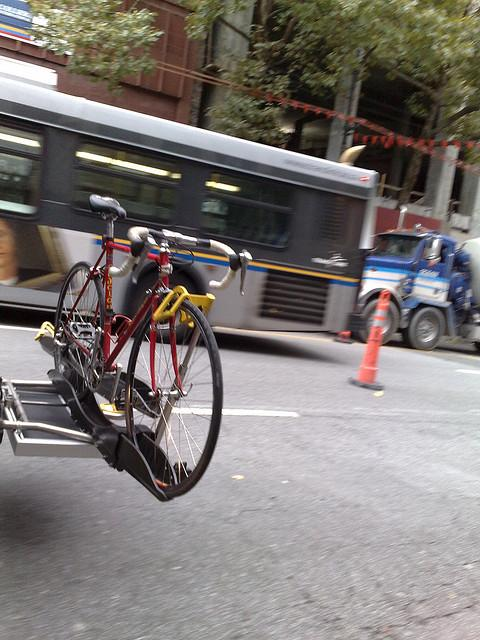What is to the left of the cone?

Choices:
A) helicopter
B) bicycle
C) television
D) bear bicycle 